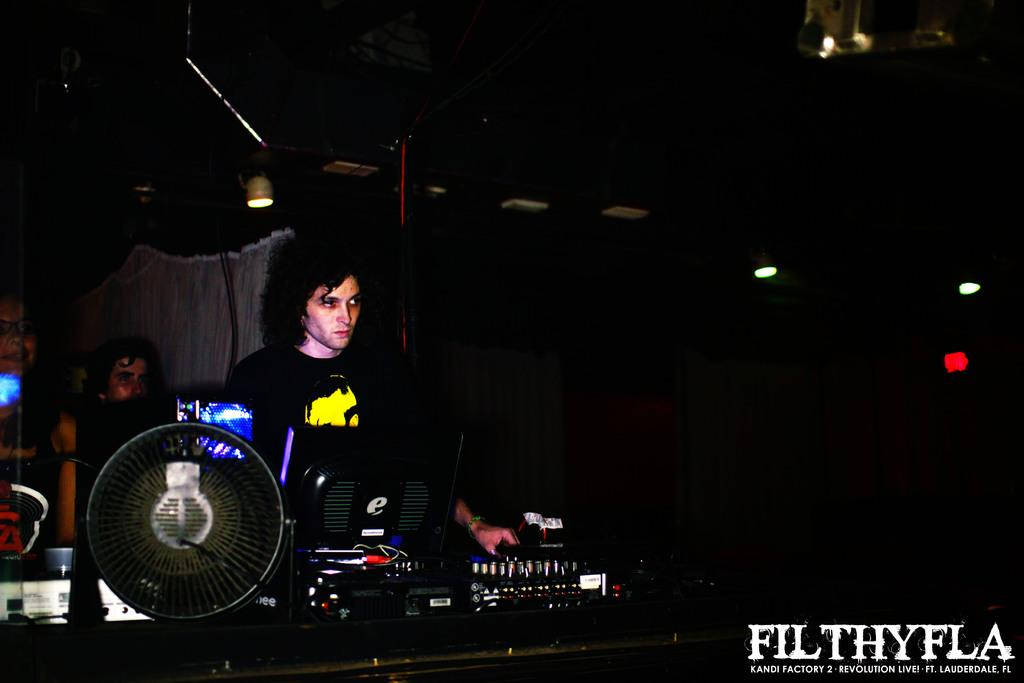How many people are in the image? There are two persons in the image. What is the main activity being performed in the image? There is a DJ setup in the image, suggesting that the persons might be DJs. What is part of the DJ setup? A monitor is part of the DJ setup. What can be seen on the left side of the image? There is a fan on the left side of the image. What is the lighting condition in the image? The background of the image is dark. What type of location might the image depict? The setting might be a pub, based on the presence of a DJ setup. Can you tell me how many rail tracks are visible in the image? There are no rail tracks present in the image. Is there a writer sitting at a desk in the image? There is no writer or desk present in the image. 